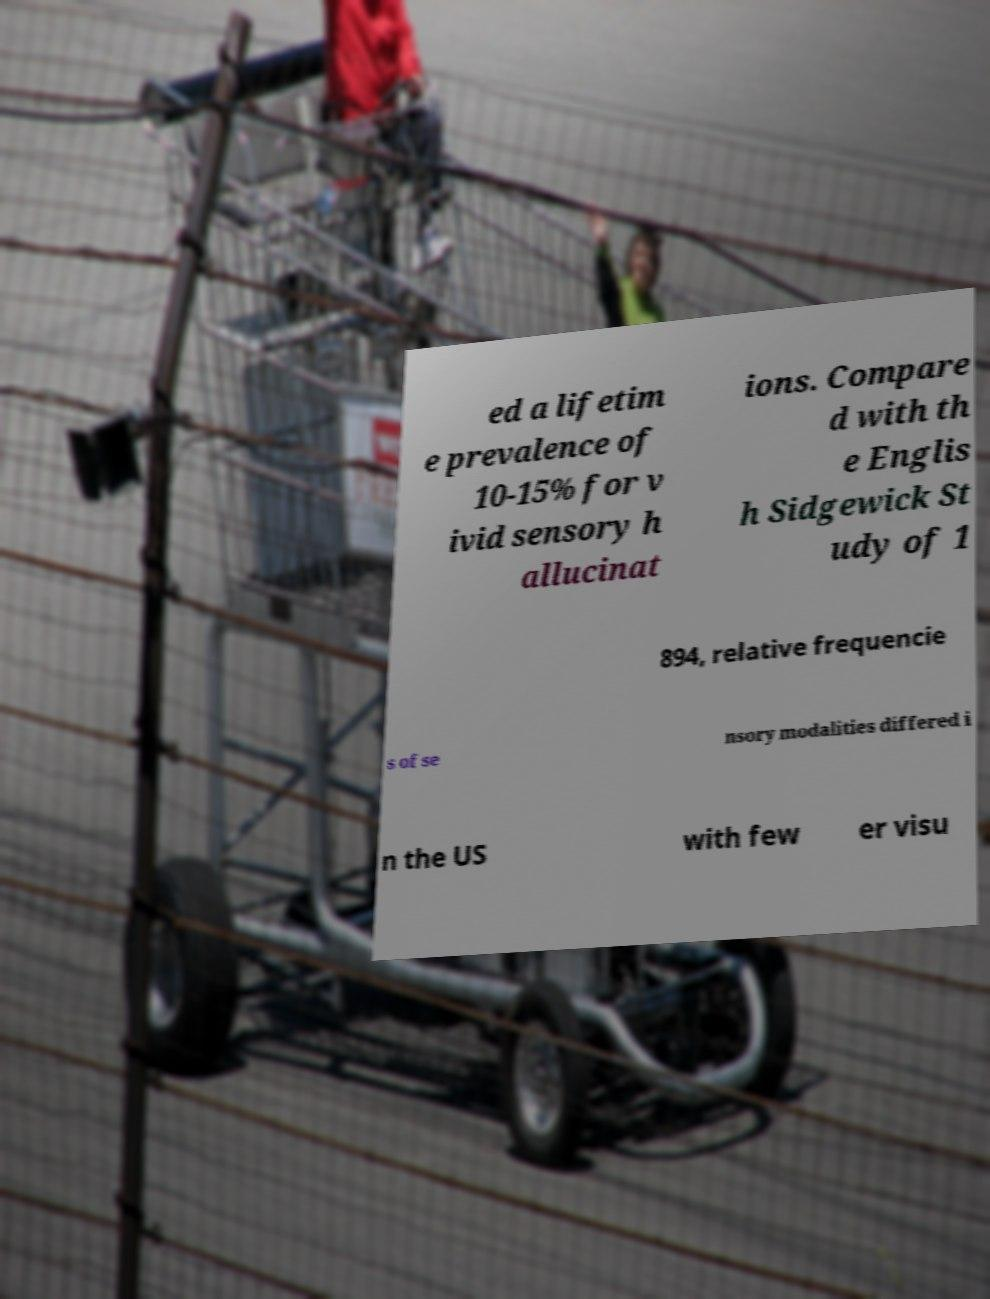Can you read and provide the text displayed in the image?This photo seems to have some interesting text. Can you extract and type it out for me? ed a lifetim e prevalence of 10-15% for v ivid sensory h allucinat ions. Compare d with th e Englis h Sidgewick St udy of 1 894, relative frequencie s of se nsory modalities differed i n the US with few er visu 